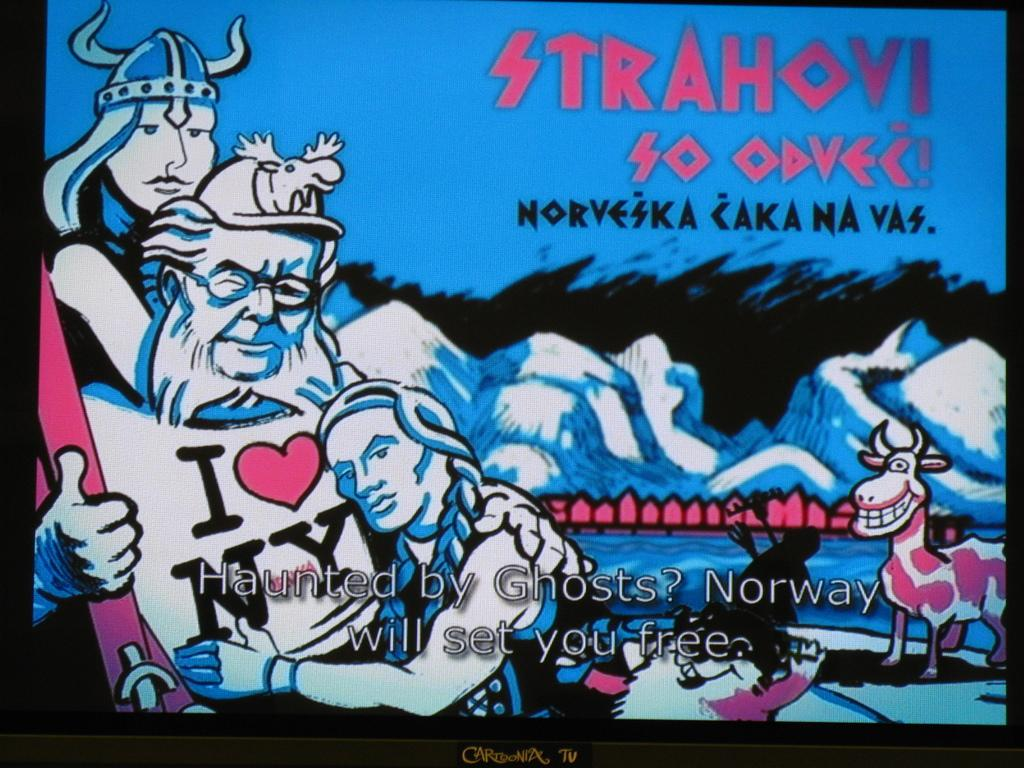Provide a one-sentence caption for the provided image. sign post of stahovi so odvec people hugging. 